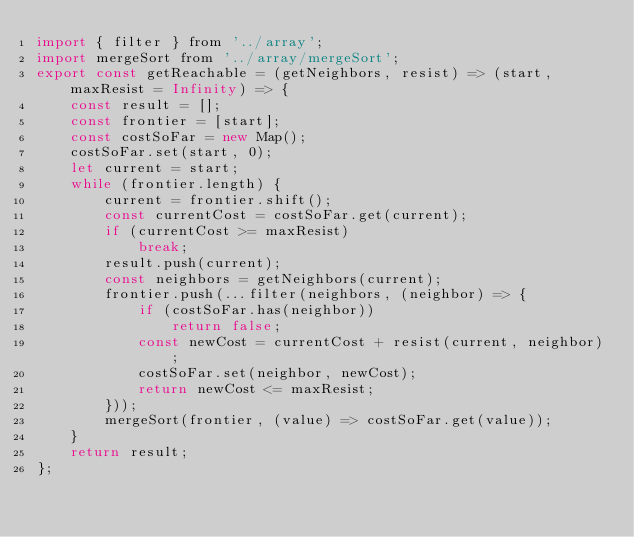<code> <loc_0><loc_0><loc_500><loc_500><_JavaScript_>import { filter } from '../array';
import mergeSort from '../array/mergeSort';
export const getReachable = (getNeighbors, resist) => (start, maxResist = Infinity) => {
    const result = [];
    const frontier = [start];
    const costSoFar = new Map();
    costSoFar.set(start, 0);
    let current = start;
    while (frontier.length) {
        current = frontier.shift();
        const currentCost = costSoFar.get(current);
        if (currentCost >= maxResist)
            break;
        result.push(current);
        const neighbors = getNeighbors(current);
        frontier.push(...filter(neighbors, (neighbor) => {
            if (costSoFar.has(neighbor))
                return false;
            const newCost = currentCost + resist(current, neighbor);
            costSoFar.set(neighbor, newCost);
            return newCost <= maxResist;
        }));
        mergeSort(frontier, (value) => costSoFar.get(value));
    }
    return result;
};
</code> 